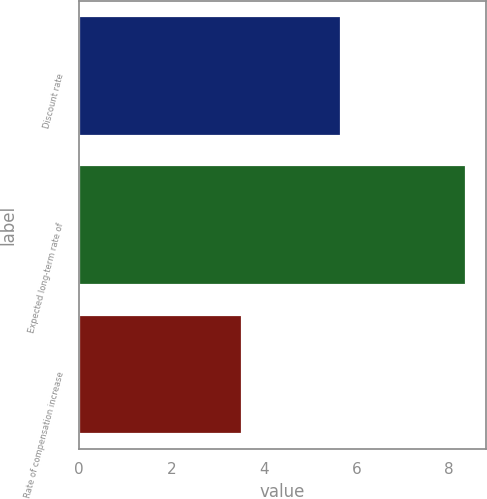<chart> <loc_0><loc_0><loc_500><loc_500><bar_chart><fcel>Discount rate<fcel>Expected long-term rate of<fcel>Rate of compensation increase<nl><fcel>5.66<fcel>8.37<fcel>3.52<nl></chart> 